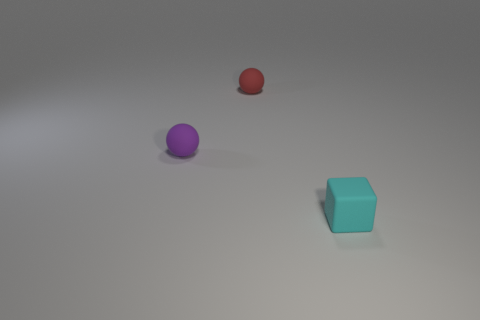Are there any other things that are the same shape as the tiny cyan matte thing?
Your answer should be very brief. No. How many other tiny objects are the same shape as the purple matte object?
Ensure brevity in your answer.  1. How many gray things are shiny cubes or small matte spheres?
Keep it short and to the point. 0. What is the size of the ball on the left side of the tiny ball that is behind the purple object?
Give a very brief answer. Small. There is another object that is the same shape as the purple matte thing; what is its material?
Keep it short and to the point. Rubber. What number of purple spheres are the same size as the block?
Your answer should be very brief. 1. Is the red matte ball the same size as the cyan object?
Make the answer very short. Yes. There is a object that is both in front of the small red sphere and behind the small matte cube; what size is it?
Your answer should be compact. Small. Is the number of small cyan things behind the tiny cyan rubber cube greater than the number of red rubber balls on the left side of the red matte sphere?
Your answer should be compact. No. There is another tiny matte object that is the same shape as the purple rubber thing; what color is it?
Give a very brief answer. Red. 